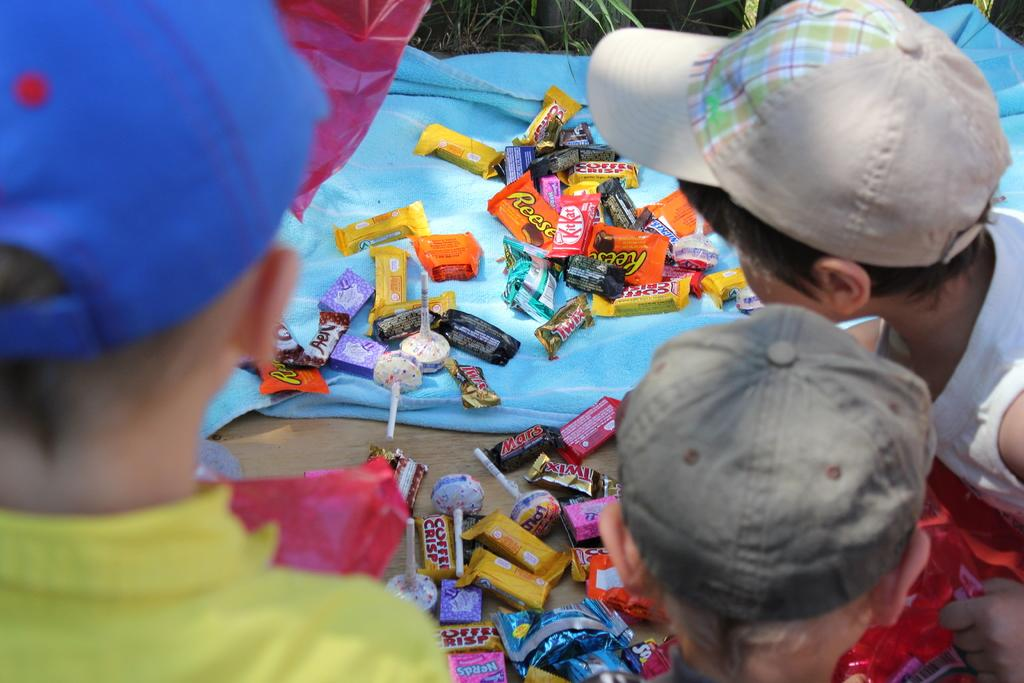How many children are present in the image? There are three kids in the image. What can be seen besides the kids in the image? There are chocolates in the image. Is there a bomb hidden among the chocolates in the image? No, there is no bomb present in the image; it only features three kids and chocolates. 